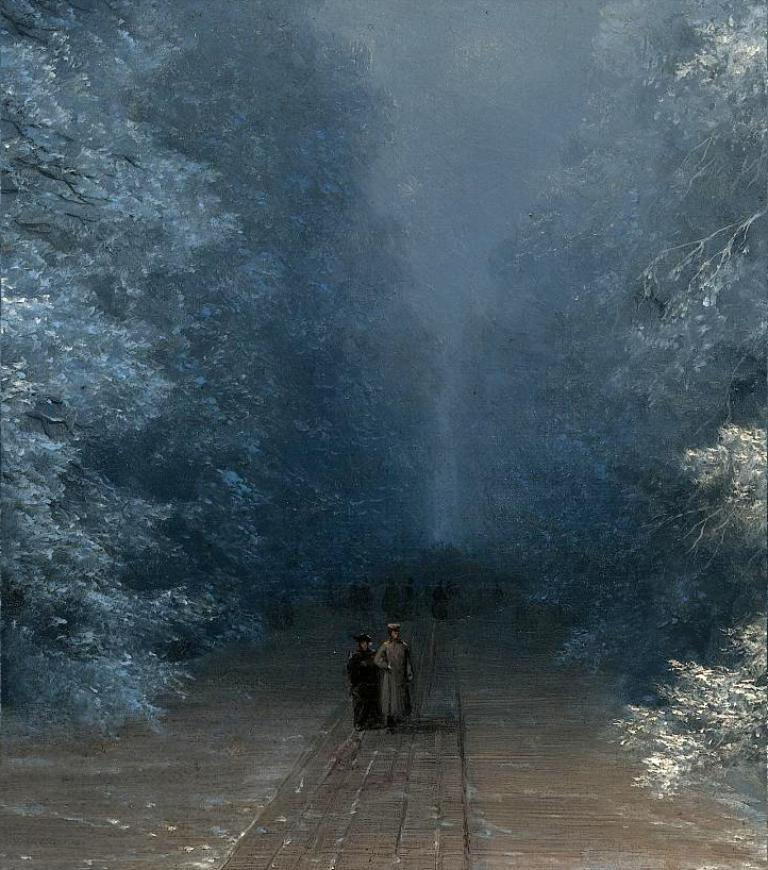What is the main subject of the image? There is a painting in the image. What elements are depicted in the painting? The painting contains trees, people, and a walkway. What type of smell can be detected from the painting in the image? There is no smell associated with the painting in the image, as it is a visual representation and not a physical object. 